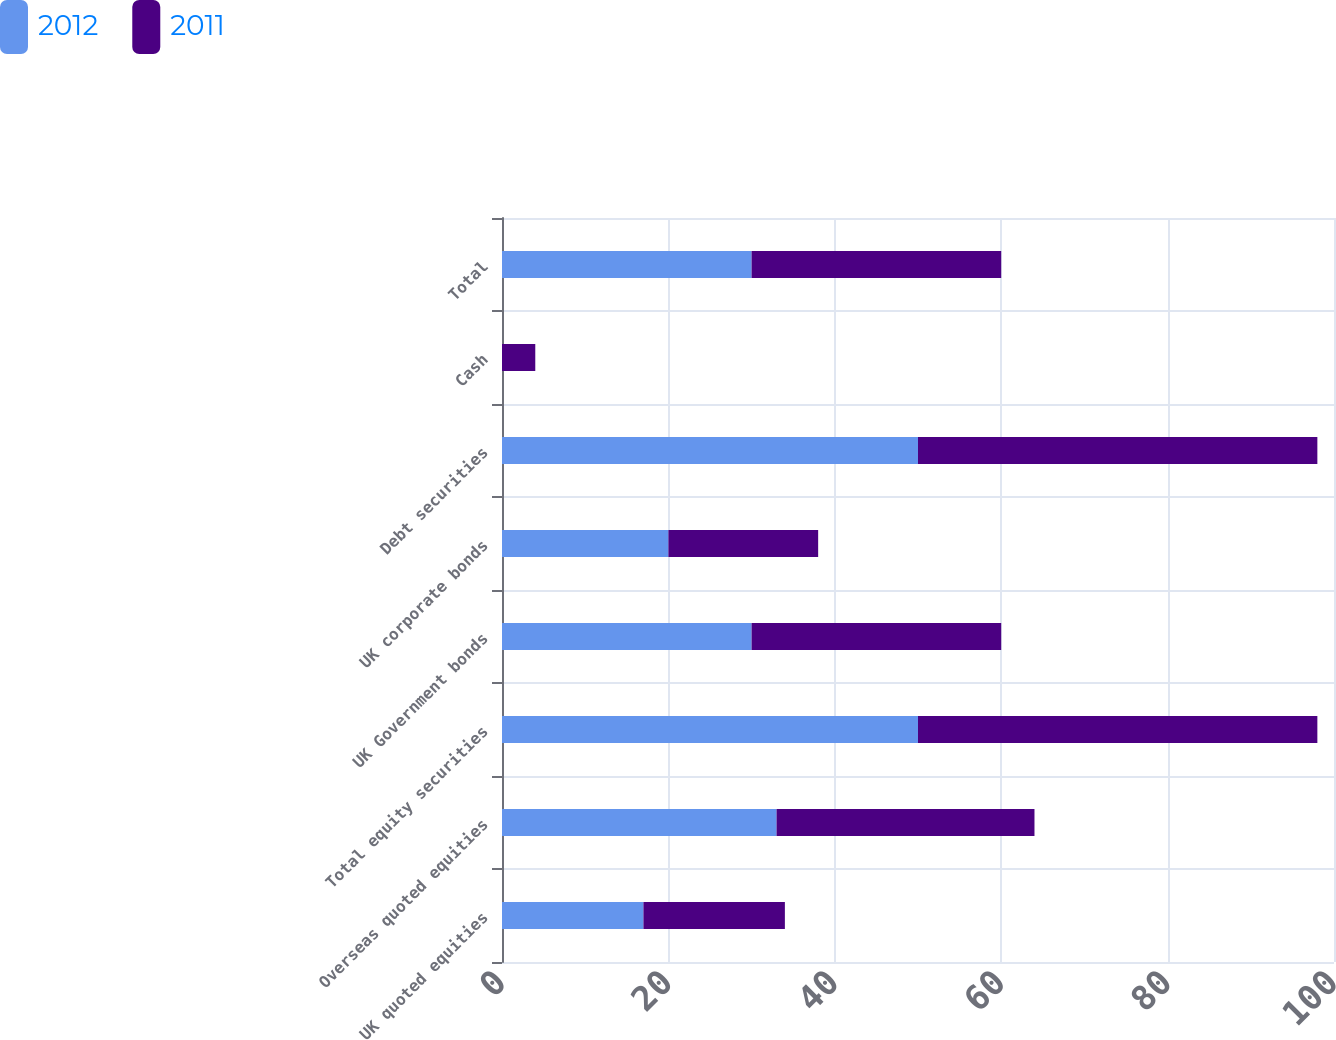Convert chart to OTSL. <chart><loc_0><loc_0><loc_500><loc_500><stacked_bar_chart><ecel><fcel>UK quoted equities<fcel>Overseas quoted equities<fcel>Total equity securities<fcel>UK Government bonds<fcel>UK corporate bonds<fcel>Debt securities<fcel>Cash<fcel>Total<nl><fcel>2012<fcel>17<fcel>33<fcel>50<fcel>30<fcel>20<fcel>50<fcel>0<fcel>30<nl><fcel>2011<fcel>17<fcel>31<fcel>48<fcel>30<fcel>18<fcel>48<fcel>4<fcel>30<nl></chart> 